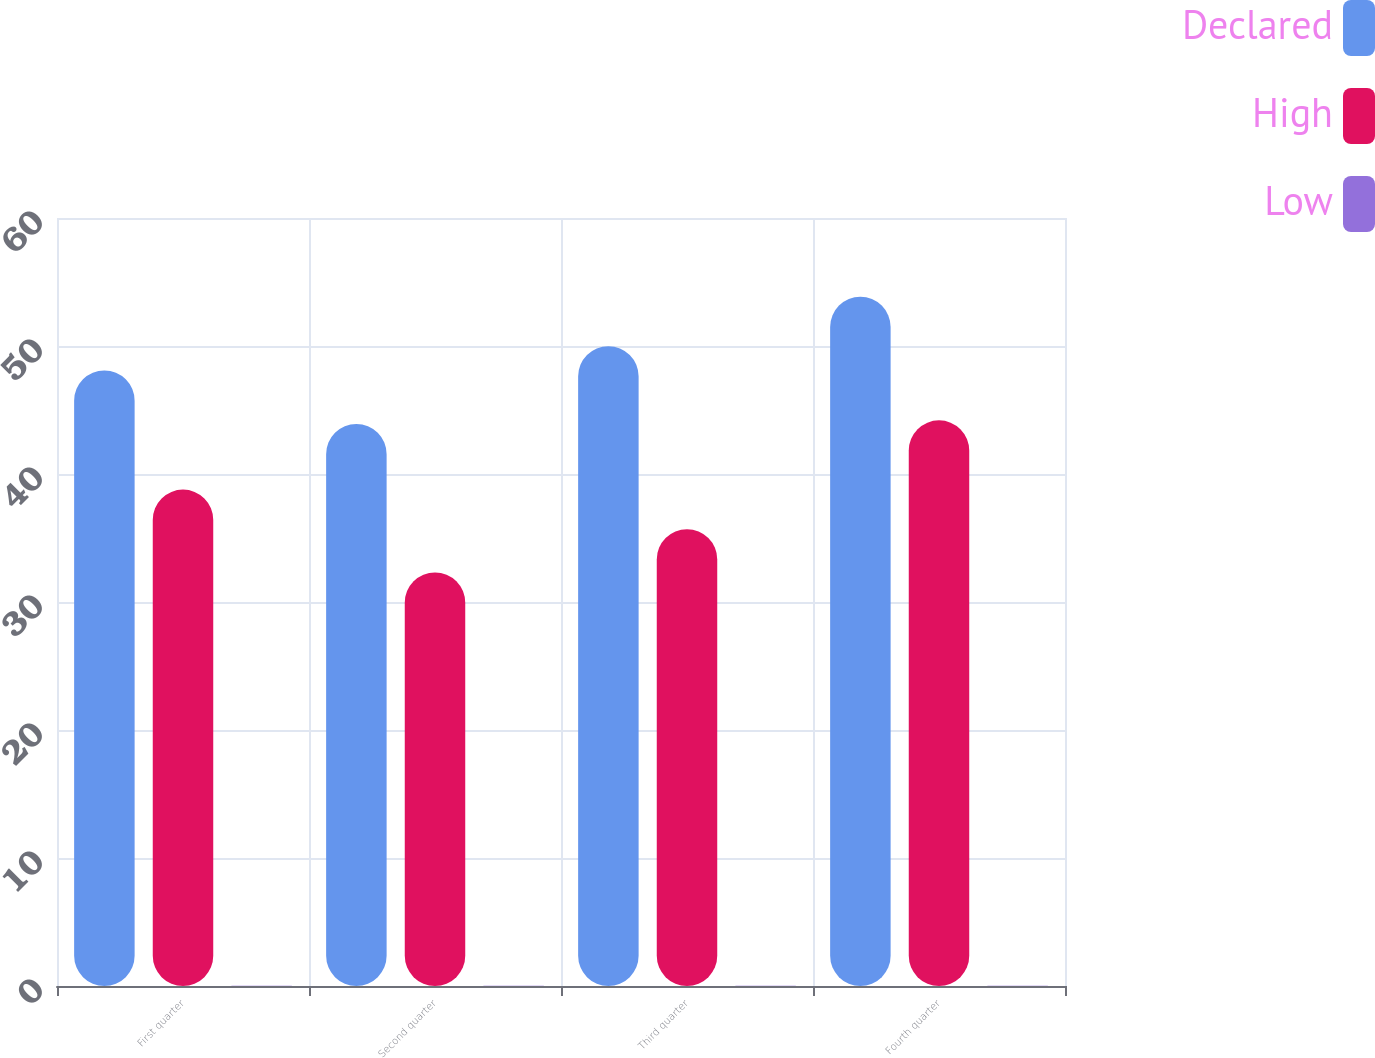<chart> <loc_0><loc_0><loc_500><loc_500><stacked_bar_chart><ecel><fcel>First quarter<fcel>Second quarter<fcel>Third quarter<fcel>Fourth quarter<nl><fcel>Declared<fcel>48.09<fcel>43.91<fcel>49.99<fcel>53.85<nl><fcel>High<fcel>38.78<fcel>32.31<fcel>35.69<fcel>44.19<nl><fcel>Low<fcel>0.01<fcel>0.01<fcel>0.01<fcel>0.01<nl></chart> 